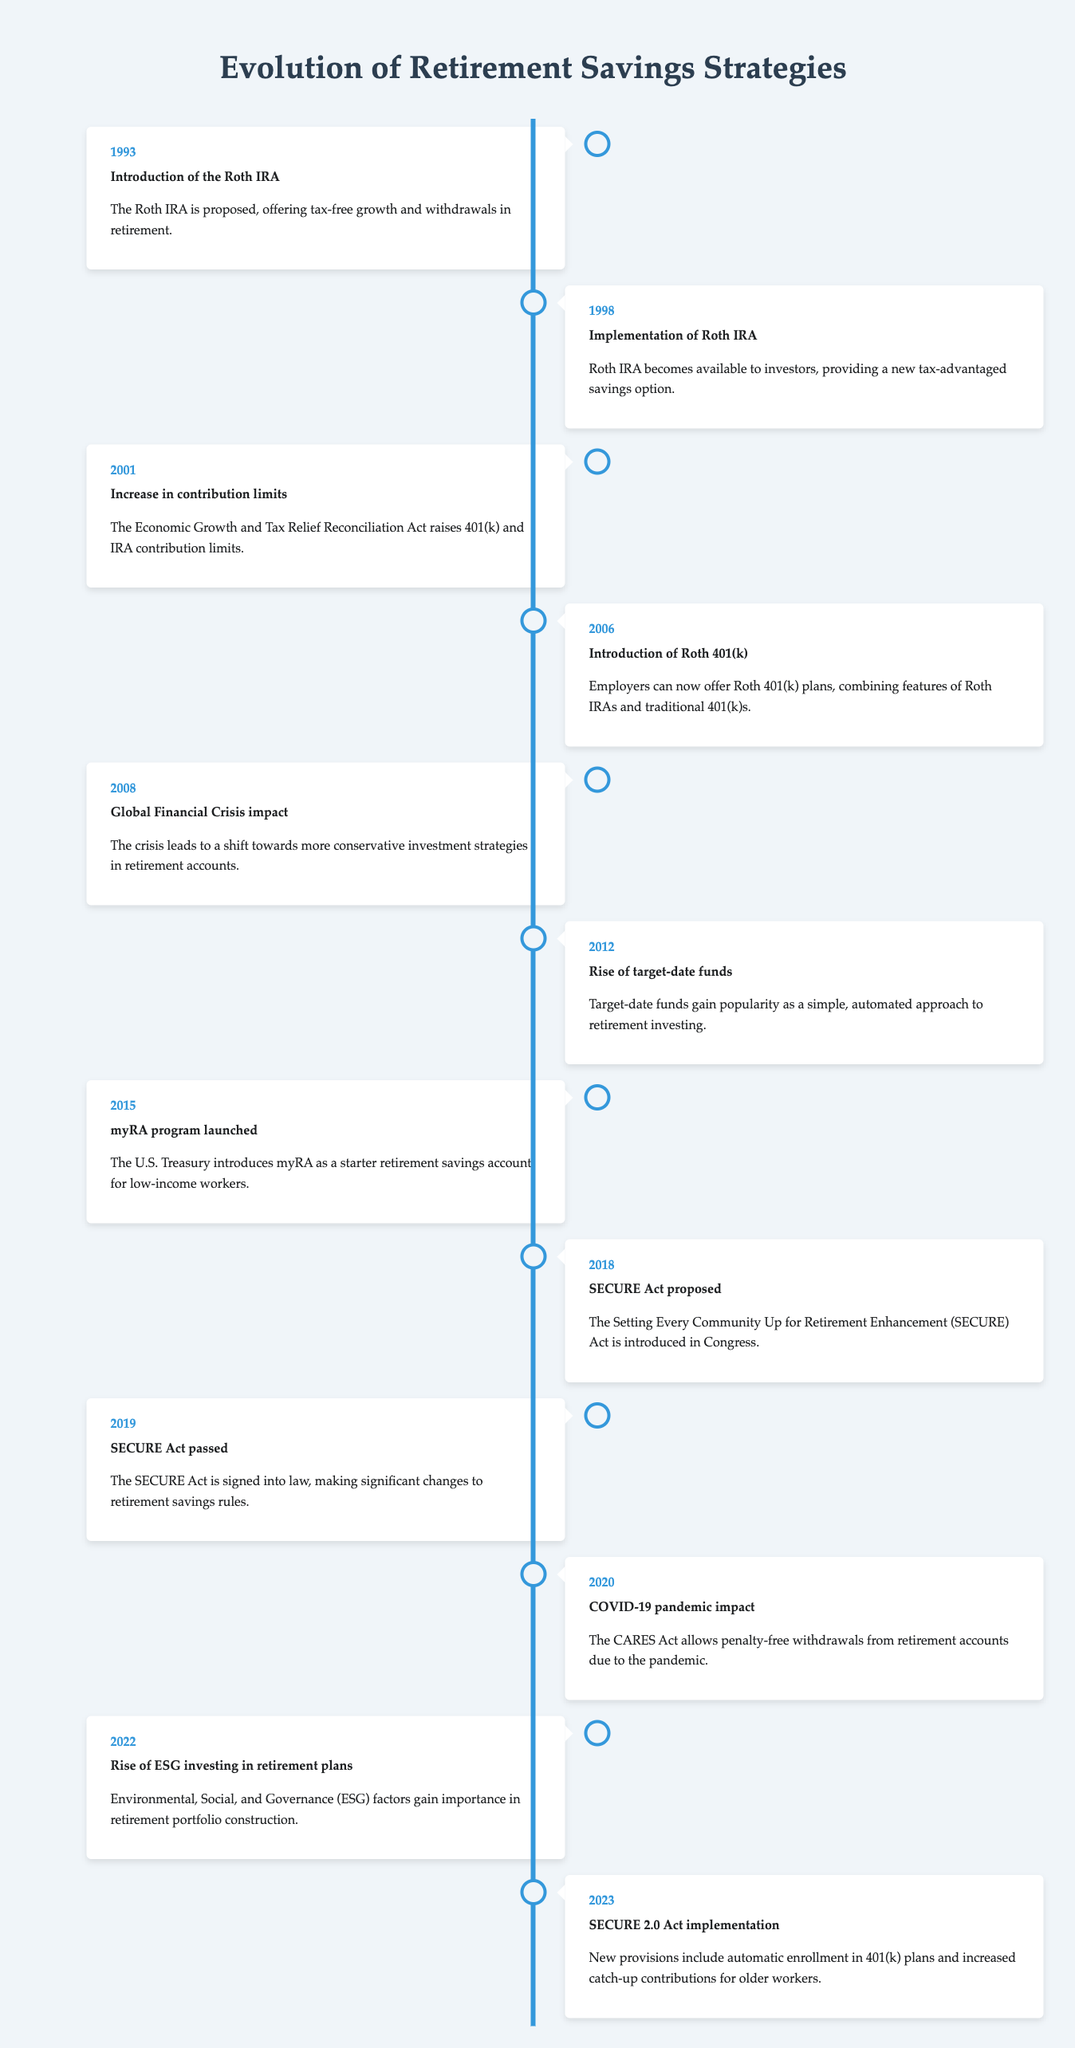What year was the Roth IRA proposed? According to the table, the Roth IRA was proposed in 1993.
Answer: 1993 What event occurred in 2019 related to retirement savings? In 2019, the SECURE Act was passed, which made significant changes to retirement savings rules.
Answer: SECURE Act passed How many significant events are listed between the years 2001 and 2010? The events between 2001 and 2010 include three: the increase in contribution limits in 2001, the introduction of Roth 401(k) in 2006, and the global financial crisis impact in 2008. Therefore, the total is three events.
Answer: 3 Was the myRA program introduced prior to or after the SECURE Act? The myRA program was launched in 2015, while the SECURE Act was passed in 2019. Therefore, the myRA program was introduced before the SECURE Act.
Answer: Prior to What significant shift in investment strategies is noted as a result of the events in 2008? The table indicates that the global financial crisis in 2008 led to a shift towards more conservative investment strategies in retirement accounts.
Answer: More conservative strategies What was the increase in contribution limits related to from the data? The increase in contribution limits in 2001 was tied to the Economic Growth and Tax Relief Reconciliation Act, which raised the limits for 401(k) and IRA accounts.
Answer: Economic Growth and Tax Relief Reconciliation Act In what year did target-date funds gain popularity? According to the table, target-date funds gained popularity in 2012 as a simple, automated approach to retirement investing.
Answer: 2012 How many years separated the implementation of the Roth IRA from the introduction of the Roth 401(k)? The Roth IRA was implemented in 1998, and the Roth 401(k) was introduced in 2006. The difference between these years is 8 years.
Answer: 8 years What was the primary focus of the SECURE 2.0 Act implemented in 2023? The SECURE 2.0 Act implemented in 2023 included new provisions such as automatic enrollment in 401(k) plans and increased catch-up contributions for older workers.
Answer: Automatic enrollment and increased catch-up contributions 